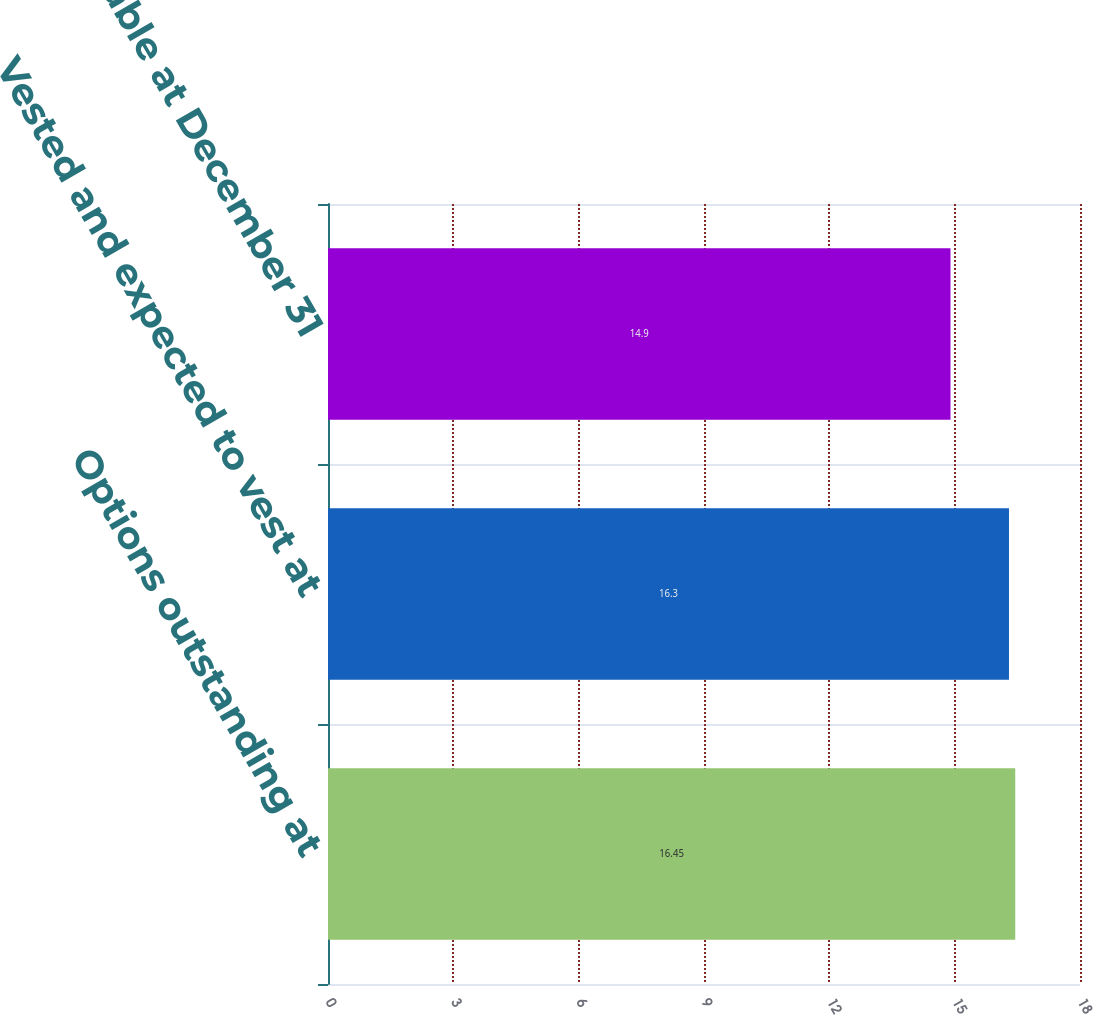Convert chart. <chart><loc_0><loc_0><loc_500><loc_500><bar_chart><fcel>Options outstanding at<fcel>Vested and expected to vest at<fcel>Exercisable at December 31<nl><fcel>16.45<fcel>16.3<fcel>14.9<nl></chart> 